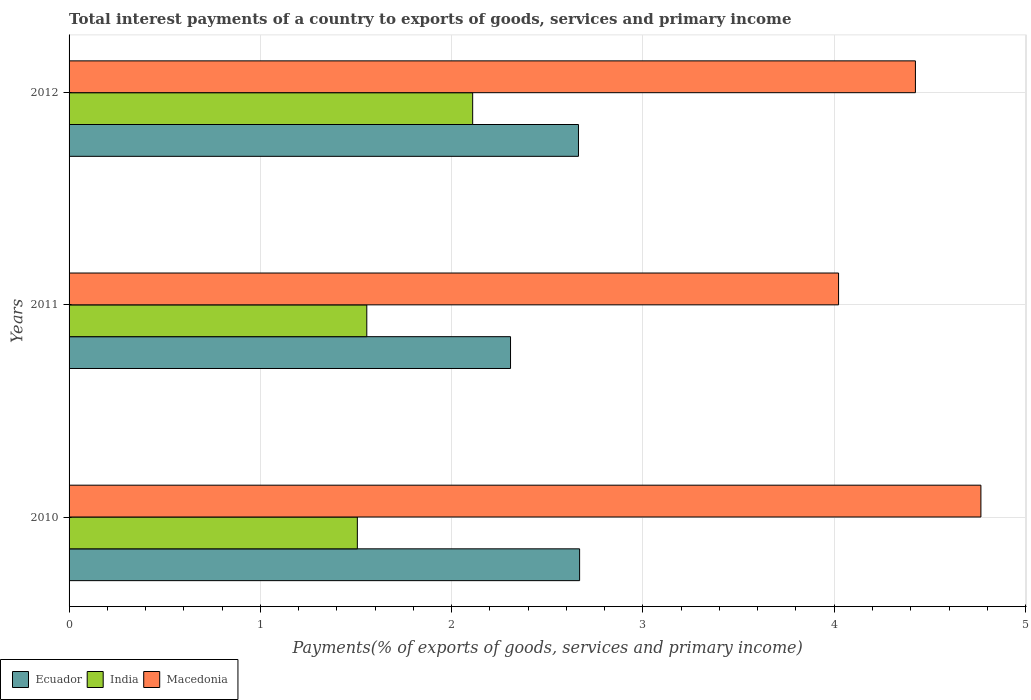How many groups of bars are there?
Offer a very short reply. 3. How many bars are there on the 2nd tick from the top?
Make the answer very short. 3. How many bars are there on the 1st tick from the bottom?
Keep it short and to the point. 3. What is the label of the 3rd group of bars from the top?
Your answer should be compact. 2010. What is the total interest payments in India in 2012?
Your answer should be compact. 2.11. Across all years, what is the maximum total interest payments in Ecuador?
Keep it short and to the point. 2.67. Across all years, what is the minimum total interest payments in Macedonia?
Keep it short and to the point. 4.02. In which year was the total interest payments in Macedonia maximum?
Keep it short and to the point. 2010. What is the total total interest payments in Macedonia in the graph?
Make the answer very short. 13.21. What is the difference between the total interest payments in India in 2011 and that in 2012?
Offer a very short reply. -0.55. What is the difference between the total interest payments in Ecuador in 2011 and the total interest payments in Macedonia in 2012?
Provide a short and direct response. -2.12. What is the average total interest payments in India per year?
Give a very brief answer. 1.72. In the year 2011, what is the difference between the total interest payments in Ecuador and total interest payments in Macedonia?
Make the answer very short. -1.71. In how many years, is the total interest payments in India greater than 4.6 %?
Give a very brief answer. 0. What is the ratio of the total interest payments in Macedonia in 2010 to that in 2012?
Your answer should be compact. 1.08. Is the total interest payments in India in 2010 less than that in 2011?
Ensure brevity in your answer.  Yes. Is the difference between the total interest payments in Ecuador in 2010 and 2012 greater than the difference between the total interest payments in Macedonia in 2010 and 2012?
Give a very brief answer. No. What is the difference between the highest and the second highest total interest payments in Macedonia?
Give a very brief answer. 0.34. What is the difference between the highest and the lowest total interest payments in Macedonia?
Your answer should be very brief. 0.74. What does the 1st bar from the top in 2010 represents?
Provide a succinct answer. Macedonia. What does the 2nd bar from the bottom in 2010 represents?
Your answer should be very brief. India. How many years are there in the graph?
Keep it short and to the point. 3. Does the graph contain any zero values?
Offer a very short reply. No. How many legend labels are there?
Ensure brevity in your answer.  3. What is the title of the graph?
Provide a short and direct response. Total interest payments of a country to exports of goods, services and primary income. What is the label or title of the X-axis?
Make the answer very short. Payments(% of exports of goods, services and primary income). What is the Payments(% of exports of goods, services and primary income) of Ecuador in 2010?
Give a very brief answer. 2.67. What is the Payments(% of exports of goods, services and primary income) in India in 2010?
Your response must be concise. 1.51. What is the Payments(% of exports of goods, services and primary income) of Macedonia in 2010?
Provide a short and direct response. 4.77. What is the Payments(% of exports of goods, services and primary income) in Ecuador in 2011?
Make the answer very short. 2.31. What is the Payments(% of exports of goods, services and primary income) of India in 2011?
Your answer should be compact. 1.56. What is the Payments(% of exports of goods, services and primary income) of Macedonia in 2011?
Make the answer very short. 4.02. What is the Payments(% of exports of goods, services and primary income) of Ecuador in 2012?
Offer a very short reply. 2.66. What is the Payments(% of exports of goods, services and primary income) of India in 2012?
Your answer should be compact. 2.11. What is the Payments(% of exports of goods, services and primary income) in Macedonia in 2012?
Keep it short and to the point. 4.42. Across all years, what is the maximum Payments(% of exports of goods, services and primary income) in Ecuador?
Your answer should be compact. 2.67. Across all years, what is the maximum Payments(% of exports of goods, services and primary income) of India?
Provide a succinct answer. 2.11. Across all years, what is the maximum Payments(% of exports of goods, services and primary income) in Macedonia?
Offer a very short reply. 4.77. Across all years, what is the minimum Payments(% of exports of goods, services and primary income) of Ecuador?
Give a very brief answer. 2.31. Across all years, what is the minimum Payments(% of exports of goods, services and primary income) in India?
Ensure brevity in your answer.  1.51. Across all years, what is the minimum Payments(% of exports of goods, services and primary income) of Macedonia?
Your answer should be compact. 4.02. What is the total Payments(% of exports of goods, services and primary income) in Ecuador in the graph?
Provide a short and direct response. 7.64. What is the total Payments(% of exports of goods, services and primary income) in India in the graph?
Your response must be concise. 5.17. What is the total Payments(% of exports of goods, services and primary income) of Macedonia in the graph?
Give a very brief answer. 13.21. What is the difference between the Payments(% of exports of goods, services and primary income) in Ecuador in 2010 and that in 2011?
Make the answer very short. 0.36. What is the difference between the Payments(% of exports of goods, services and primary income) in India in 2010 and that in 2011?
Offer a terse response. -0.05. What is the difference between the Payments(% of exports of goods, services and primary income) of Macedonia in 2010 and that in 2011?
Your response must be concise. 0.74. What is the difference between the Payments(% of exports of goods, services and primary income) of Ecuador in 2010 and that in 2012?
Your response must be concise. 0.01. What is the difference between the Payments(% of exports of goods, services and primary income) in India in 2010 and that in 2012?
Your response must be concise. -0.6. What is the difference between the Payments(% of exports of goods, services and primary income) in Macedonia in 2010 and that in 2012?
Keep it short and to the point. 0.34. What is the difference between the Payments(% of exports of goods, services and primary income) in Ecuador in 2011 and that in 2012?
Make the answer very short. -0.36. What is the difference between the Payments(% of exports of goods, services and primary income) in India in 2011 and that in 2012?
Offer a terse response. -0.55. What is the difference between the Payments(% of exports of goods, services and primary income) of Macedonia in 2011 and that in 2012?
Your response must be concise. -0.4. What is the difference between the Payments(% of exports of goods, services and primary income) of Ecuador in 2010 and the Payments(% of exports of goods, services and primary income) of India in 2011?
Provide a short and direct response. 1.11. What is the difference between the Payments(% of exports of goods, services and primary income) in Ecuador in 2010 and the Payments(% of exports of goods, services and primary income) in Macedonia in 2011?
Your answer should be compact. -1.35. What is the difference between the Payments(% of exports of goods, services and primary income) of India in 2010 and the Payments(% of exports of goods, services and primary income) of Macedonia in 2011?
Offer a very short reply. -2.52. What is the difference between the Payments(% of exports of goods, services and primary income) in Ecuador in 2010 and the Payments(% of exports of goods, services and primary income) in India in 2012?
Your response must be concise. 0.56. What is the difference between the Payments(% of exports of goods, services and primary income) of Ecuador in 2010 and the Payments(% of exports of goods, services and primary income) of Macedonia in 2012?
Offer a terse response. -1.76. What is the difference between the Payments(% of exports of goods, services and primary income) in India in 2010 and the Payments(% of exports of goods, services and primary income) in Macedonia in 2012?
Your response must be concise. -2.92. What is the difference between the Payments(% of exports of goods, services and primary income) in Ecuador in 2011 and the Payments(% of exports of goods, services and primary income) in India in 2012?
Provide a short and direct response. 0.2. What is the difference between the Payments(% of exports of goods, services and primary income) of Ecuador in 2011 and the Payments(% of exports of goods, services and primary income) of Macedonia in 2012?
Offer a very short reply. -2.12. What is the difference between the Payments(% of exports of goods, services and primary income) of India in 2011 and the Payments(% of exports of goods, services and primary income) of Macedonia in 2012?
Offer a terse response. -2.87. What is the average Payments(% of exports of goods, services and primary income) in Ecuador per year?
Make the answer very short. 2.55. What is the average Payments(% of exports of goods, services and primary income) of India per year?
Your response must be concise. 1.72. What is the average Payments(% of exports of goods, services and primary income) in Macedonia per year?
Your answer should be very brief. 4.4. In the year 2010, what is the difference between the Payments(% of exports of goods, services and primary income) of Ecuador and Payments(% of exports of goods, services and primary income) of India?
Offer a terse response. 1.16. In the year 2010, what is the difference between the Payments(% of exports of goods, services and primary income) in Ecuador and Payments(% of exports of goods, services and primary income) in Macedonia?
Provide a short and direct response. -2.1. In the year 2010, what is the difference between the Payments(% of exports of goods, services and primary income) of India and Payments(% of exports of goods, services and primary income) of Macedonia?
Give a very brief answer. -3.26. In the year 2011, what is the difference between the Payments(% of exports of goods, services and primary income) in Ecuador and Payments(% of exports of goods, services and primary income) in India?
Make the answer very short. 0.75. In the year 2011, what is the difference between the Payments(% of exports of goods, services and primary income) in Ecuador and Payments(% of exports of goods, services and primary income) in Macedonia?
Provide a succinct answer. -1.71. In the year 2011, what is the difference between the Payments(% of exports of goods, services and primary income) of India and Payments(% of exports of goods, services and primary income) of Macedonia?
Your answer should be compact. -2.47. In the year 2012, what is the difference between the Payments(% of exports of goods, services and primary income) in Ecuador and Payments(% of exports of goods, services and primary income) in India?
Your response must be concise. 0.55. In the year 2012, what is the difference between the Payments(% of exports of goods, services and primary income) of Ecuador and Payments(% of exports of goods, services and primary income) of Macedonia?
Keep it short and to the point. -1.76. In the year 2012, what is the difference between the Payments(% of exports of goods, services and primary income) in India and Payments(% of exports of goods, services and primary income) in Macedonia?
Provide a succinct answer. -2.31. What is the ratio of the Payments(% of exports of goods, services and primary income) in Ecuador in 2010 to that in 2011?
Give a very brief answer. 1.16. What is the ratio of the Payments(% of exports of goods, services and primary income) of India in 2010 to that in 2011?
Give a very brief answer. 0.97. What is the ratio of the Payments(% of exports of goods, services and primary income) of Macedonia in 2010 to that in 2011?
Your answer should be compact. 1.19. What is the ratio of the Payments(% of exports of goods, services and primary income) in India in 2010 to that in 2012?
Give a very brief answer. 0.71. What is the ratio of the Payments(% of exports of goods, services and primary income) in Macedonia in 2010 to that in 2012?
Offer a very short reply. 1.08. What is the ratio of the Payments(% of exports of goods, services and primary income) of Ecuador in 2011 to that in 2012?
Provide a succinct answer. 0.87. What is the ratio of the Payments(% of exports of goods, services and primary income) of India in 2011 to that in 2012?
Offer a terse response. 0.74. What is the ratio of the Payments(% of exports of goods, services and primary income) in Macedonia in 2011 to that in 2012?
Offer a very short reply. 0.91. What is the difference between the highest and the second highest Payments(% of exports of goods, services and primary income) of Ecuador?
Your response must be concise. 0.01. What is the difference between the highest and the second highest Payments(% of exports of goods, services and primary income) of India?
Give a very brief answer. 0.55. What is the difference between the highest and the second highest Payments(% of exports of goods, services and primary income) in Macedonia?
Ensure brevity in your answer.  0.34. What is the difference between the highest and the lowest Payments(% of exports of goods, services and primary income) of Ecuador?
Give a very brief answer. 0.36. What is the difference between the highest and the lowest Payments(% of exports of goods, services and primary income) of India?
Make the answer very short. 0.6. What is the difference between the highest and the lowest Payments(% of exports of goods, services and primary income) of Macedonia?
Offer a terse response. 0.74. 